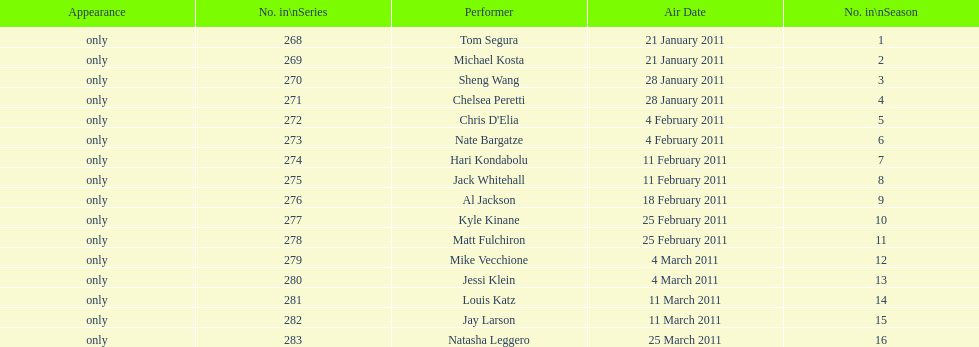How many comedians made their only appearance on comedy central presents in season 15? 16. 